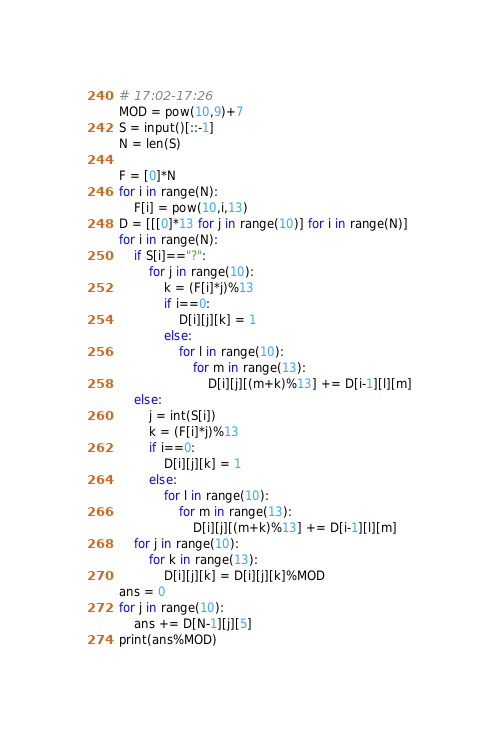Convert code to text. <code><loc_0><loc_0><loc_500><loc_500><_Python_># 17:02-17:26
MOD = pow(10,9)+7
S = input()[::-1]
N = len(S)

F = [0]*N
for i in range(N):
    F[i] = pow(10,i,13)
D = [[[0]*13 for j in range(10)] for i in range(N)]
for i in range(N):
    if S[i]=="?":
        for j in range(10):
            k = (F[i]*j)%13
            if i==0:
                D[i][j][k] = 1
            else:
                for l in range(10):
                    for m in range(13):
                        D[i][j][(m+k)%13] += D[i-1][l][m]
    else:
        j = int(S[i])
        k = (F[i]*j)%13
        if i==0:
            D[i][j][k] = 1
        else:
            for l in range(10):
                for m in range(13):
                    D[i][j][(m+k)%13] += D[i-1][l][m]
    for j in range(10):
        for k in range(13):
            D[i][j][k] = D[i][j][k]%MOD
ans = 0
for j in range(10):
    ans += D[N-1][j][5]
print(ans%MOD)</code> 